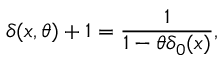Convert formula to latex. <formula><loc_0><loc_0><loc_500><loc_500>\delta ( x , \theta ) + 1 = \frac { 1 } { 1 - \theta \delta _ { 0 } ( x ) } ,</formula> 